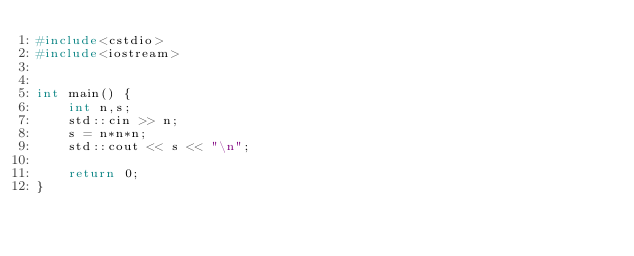Convert code to text. <code><loc_0><loc_0><loc_500><loc_500><_C++_>#include<cstdio>
#include<iostream>


int main() {
    int n,s;
    std::cin >> n;
    s = n*n*n;
    std::cout << s << "\n";
    
    return 0;
}
</code> 